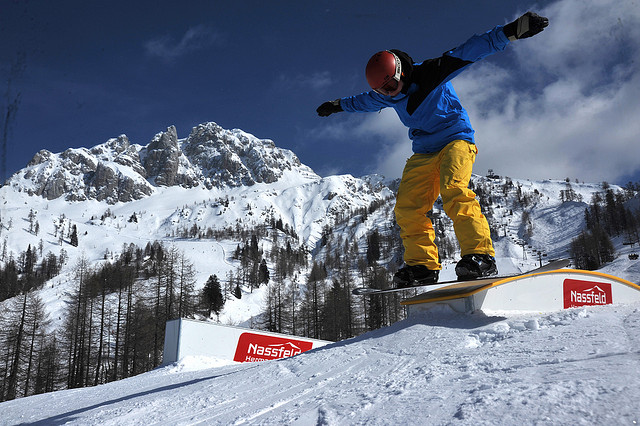What's the main activity happening in the image? The main activity in the image is snowboarding. A snowboarder is executing a trick on a rail, showing their balance and skills on the snow-covered slope. 